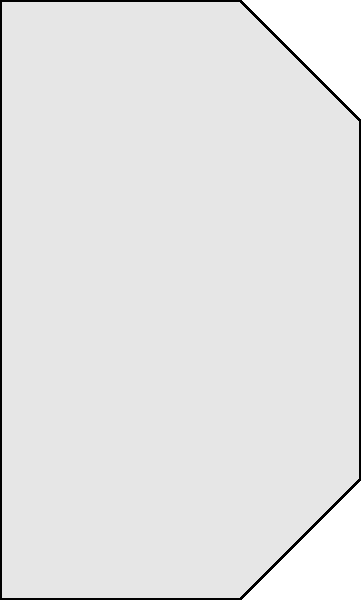Which part of the baseball glove, as shown in the diagram, is crucial for absorbing the impact of a caught ball and was often reinforced in gloves used by African American fielders in the Negro Leagues to extend their durability? To answer this question, we need to consider the following points:

1. The anatomy of a baseball glove: The main parts are the web, palm, heel, lacing, and finger stalls.

2. Function of each part:
   - Web: Helps secure the ball when caught
   - Palm: Provides a large surface area for catching
   - Heel: Absorbs impact and provides structure
   - Lacing: Holds the glove together
   - Finger stalls: Allow for finger movement and control

3. Impact absorption: The heel of the glove is primarily responsible for absorbing the impact of a caught ball. It's located at the bottom of the glove where the hand's heel rests.

4. Historical context: In the Negro Leagues, players often had to make do with limited resources. Gloves were expensive and had to last longer.

5. Reinforcement for durability: To extend the life of their gloves, players and equipment managers would often reinforce the heel area, as it was subject to the most wear and tear from repeated impacts.

Given these factors, the heel of the glove was crucial for absorbing impact and was often reinforced in gloves used by African American fielders in the Negro Leagues to extend their durability.
Answer: Heel 